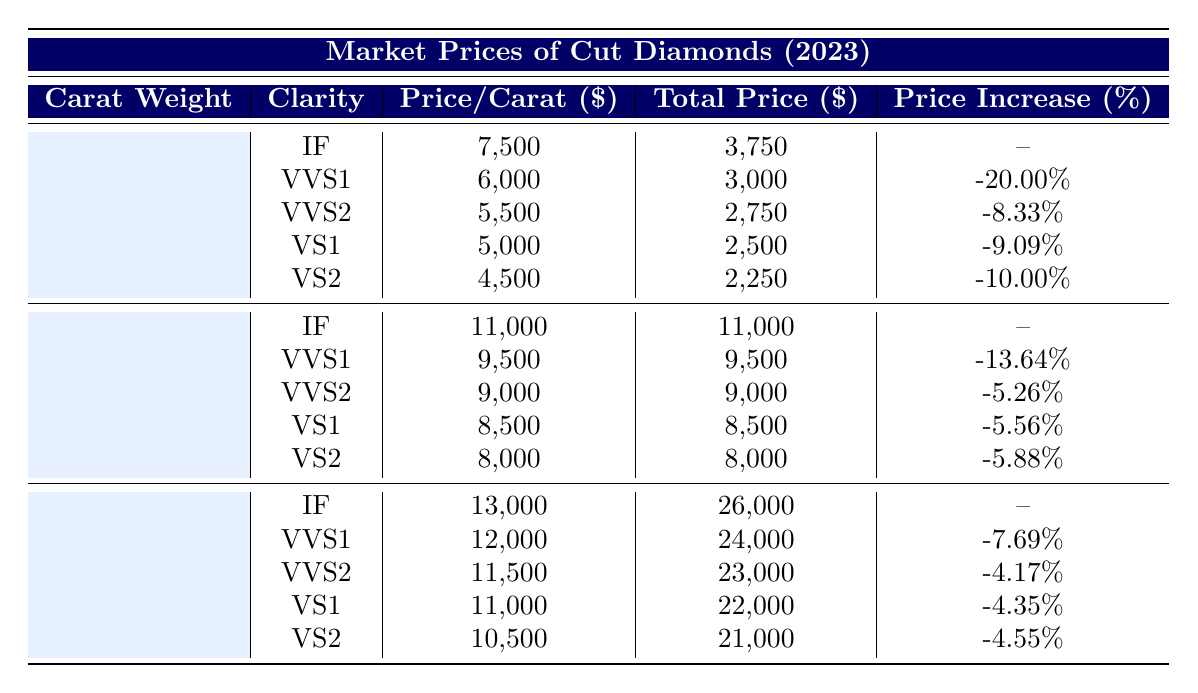What is the total price of a 1.00 carat diamond with VVS2 clarity? The total price for a 1.00 carat diamond with VVS2 clarity is listed directly in the table under the appropriate section, which shows a total price of 9,000 dollars.
Answer: 9,000 What is the price per carat for the highest clarity (IF) diamond weighing 2.00 carats? The table specifies that the price per carat for a 2.00 carat diamond of IF clarity is given in the corresponding row, which is 13,000 dollars.
Answer: 13,000 Is the total price of a 0.50 carat VS2 diamond greater than that of a 1.00 carat VVS1 diamond? The total price for a 0.50 carat VS2 diamond is 2,250 dollars, while the total price for a 1.00 carat VVS1 diamond is 9,500 dollars. Since 2,250 is less than 9,500, the statement is false.
Answer: No What is the price increase percentage for a 1.00 carat VS1 diamond compared to its IF counterpart? To find the price increase percentage, subtract the price per carat of the VS1 diamond (8,500) from that of the IF diamond (11,000), yielding a difference of 2,500 dollars. The price increase percentage is (2,500/11,000)*100 ≈ 22.73 percent. Thus, the increase is approximately 22.73 percent.
Answer: 22.73% Which carat weight has the highest total price for any clarity? By scanning the total prices in the table, it is observed that the total price for a 2.00 carat IF diamond is 26,000 dollars, which is indeed the highest of any entry in the table.
Answer: 2.00 carats with IF clarity 